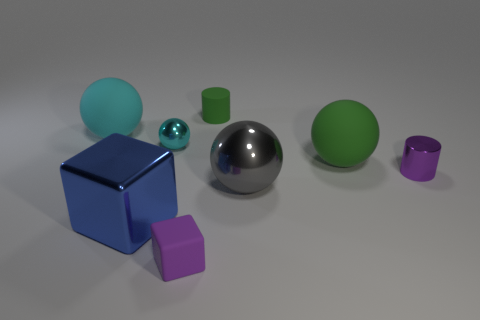Subtract 1 balls. How many balls are left? 3 Subtract all cylinders. How many objects are left? 6 Add 1 tiny purple metallic cylinders. How many objects exist? 9 Subtract all purple balls. Subtract all purple cylinders. How many balls are left? 4 Subtract all spheres. Subtract all big blocks. How many objects are left? 3 Add 3 tiny green cylinders. How many tiny green cylinders are left? 4 Add 1 tiny purple cubes. How many tiny purple cubes exist? 2 Subtract 1 cyan balls. How many objects are left? 7 